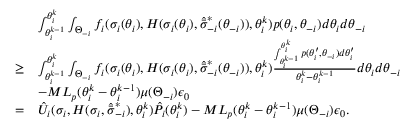Convert formula to latex. <formula><loc_0><loc_0><loc_500><loc_500>\begin{array} { r l } & { \int _ { \theta _ { i } ^ { k - 1 } } ^ { \theta _ { i } ^ { k } } \int _ { \Theta _ { - i } } f _ { i } ( \sigma _ { i } ( \theta _ { i } ) , H ( \sigma _ { i } ( \theta _ { i } ) , \hat { \bar { \sigma } } _ { - i } ^ { * } ( \theta _ { - i } ) ) , \theta _ { i } ^ { k } ) p ( \theta _ { i } , \theta _ { - i } ) d \theta _ { i } d \theta _ { - i } } \\ { \geq } & { \int _ { \theta _ { i } ^ { k - 1 } } ^ { \theta _ { i } ^ { k } } \int _ { \Theta _ { - i } } f _ { i } ( \sigma _ { i } ( \theta _ { i } ) , H ( \sigma _ { i } ( \theta _ { i } ) , \hat { \bar { \sigma } } _ { - i } ^ { * } ( \theta _ { - i } ) ) , \theta _ { i } ^ { k } ) \frac { \int _ { \theta _ { i } ^ { k - 1 } } ^ { \theta _ { i } ^ { k } } p ( \theta _ { i } ^ { \prime } , \theta _ { - i } ) d \theta _ { i } ^ { \prime } } { \theta _ { i } ^ { k } - \theta _ { i } ^ { k - 1 } } d \theta _ { i } d \theta _ { - i } } \\ & { - M L _ { p } ( \theta _ { i } ^ { k } - \theta _ { i } ^ { k - 1 } ) \mu ( \Theta _ { - i } ) \epsilon _ { 0 } } \\ { = } & { \hat { U } _ { i } ( \sigma _ { i } , H ( \sigma _ { i } , \hat { \bar { \sigma } } _ { - i } ^ { * } ) , \theta _ { i } ^ { k } ) \hat { P } _ { i } ( \theta _ { i } ^ { k } ) - M L _ { p } ( \theta _ { i } ^ { k } - \theta _ { i } ^ { k - 1 } ) \mu ( \Theta _ { - i } ) \epsilon _ { 0 } . } \end{array}</formula> 